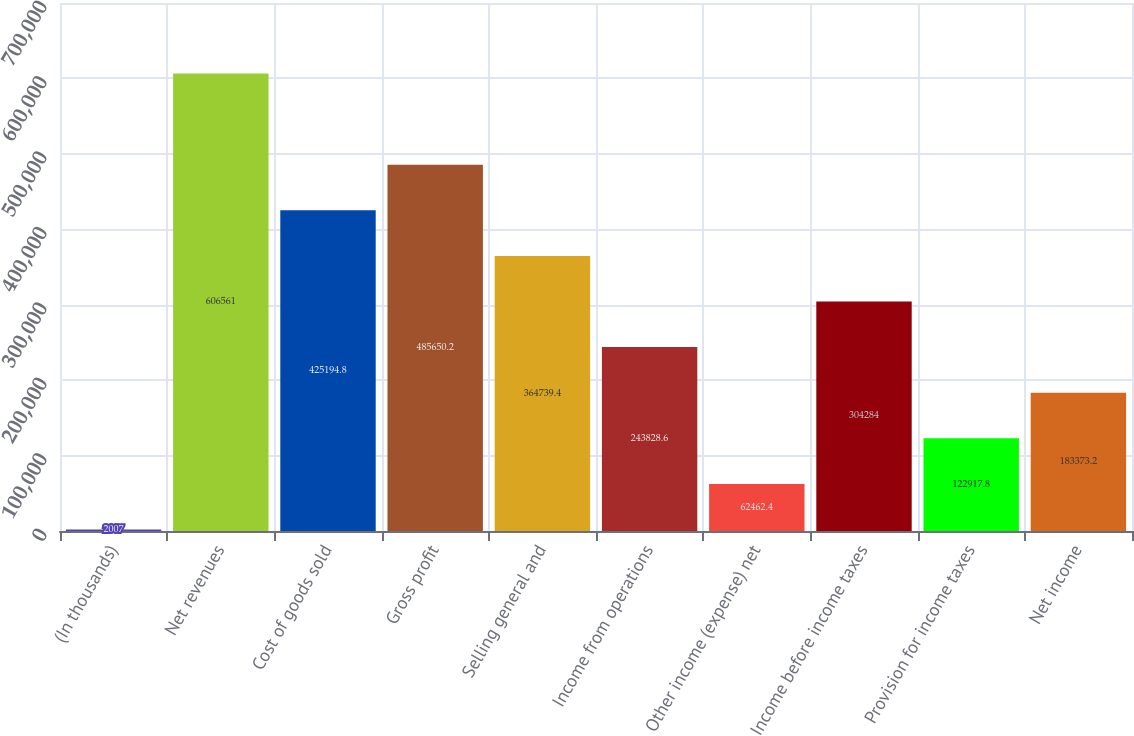<chart> <loc_0><loc_0><loc_500><loc_500><bar_chart><fcel>(In thousands)<fcel>Net revenues<fcel>Cost of goods sold<fcel>Gross profit<fcel>Selling general and<fcel>Income from operations<fcel>Other income (expense) net<fcel>Income before income taxes<fcel>Provision for income taxes<fcel>Net income<nl><fcel>2007<fcel>606561<fcel>425195<fcel>485650<fcel>364739<fcel>243829<fcel>62462.4<fcel>304284<fcel>122918<fcel>183373<nl></chart> 